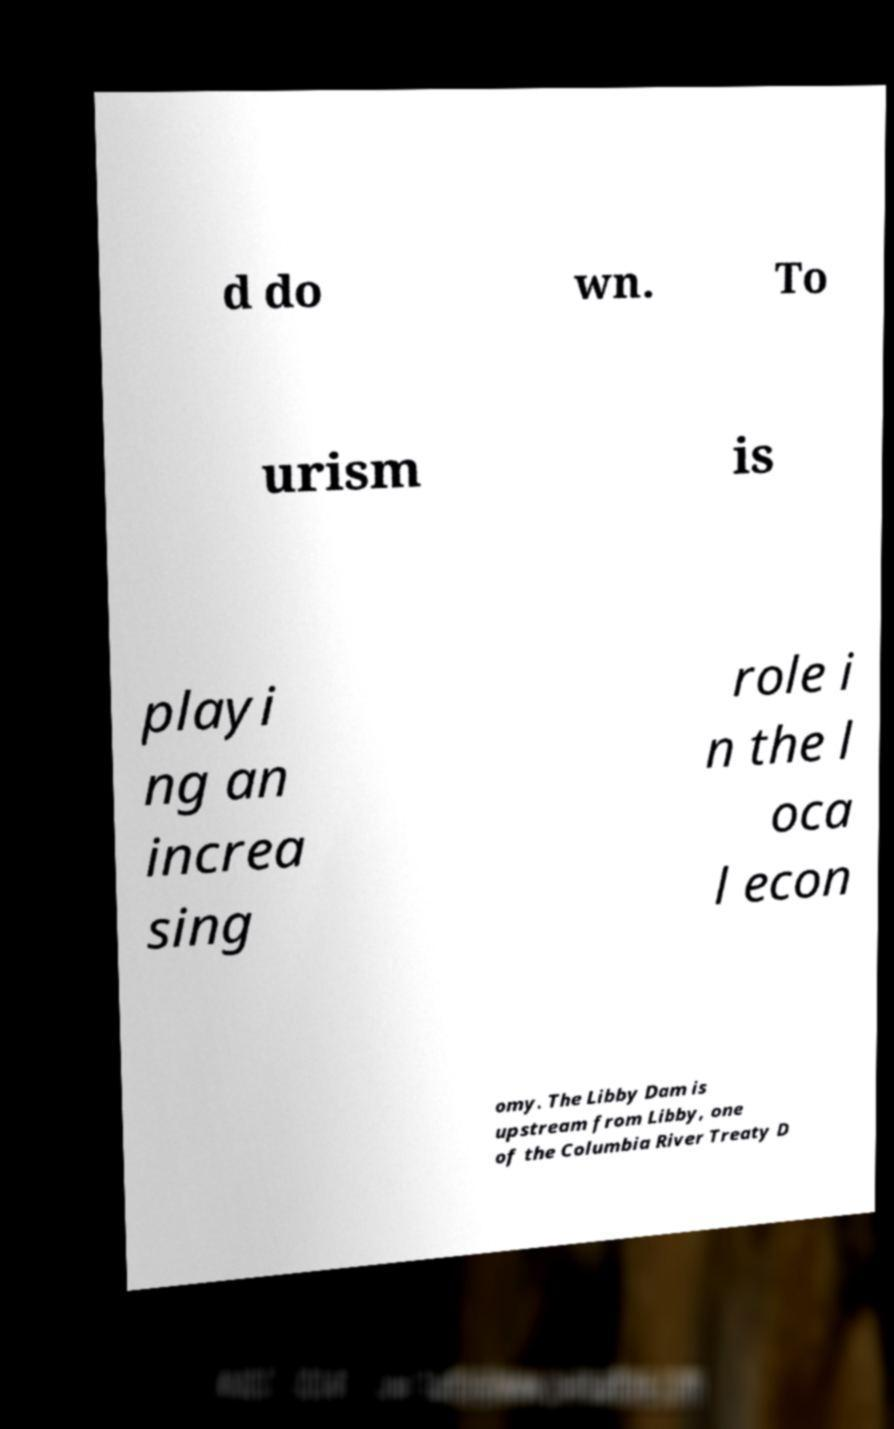I need the written content from this picture converted into text. Can you do that? d do wn. To urism is playi ng an increa sing role i n the l oca l econ omy. The Libby Dam is upstream from Libby, one of the Columbia River Treaty D 